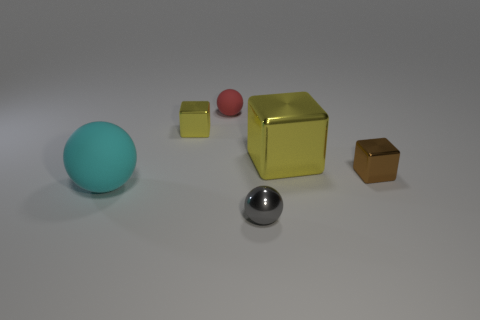There is a brown thing; are there any shiny spheres behind it?
Provide a succinct answer. No. What size is the thing that is the same color as the large shiny block?
Offer a very short reply. Small. Are there any small yellow cylinders that have the same material as the big cyan thing?
Give a very brief answer. No. What is the color of the big ball?
Offer a terse response. Cyan. Does the yellow metallic thing that is right of the tiny gray sphere have the same shape as the gray object?
Offer a terse response. No. What shape is the thing that is to the right of the yellow cube that is in front of the small block that is left of the tiny gray sphere?
Give a very brief answer. Cube. There is a thing in front of the cyan rubber object; what material is it?
Offer a terse response. Metal. What color is the metal thing that is the same size as the cyan rubber sphere?
Ensure brevity in your answer.  Yellow. What number of other things are the same shape as the large shiny thing?
Your answer should be very brief. 2. Does the red matte ball have the same size as the cyan matte ball?
Keep it short and to the point. No. 